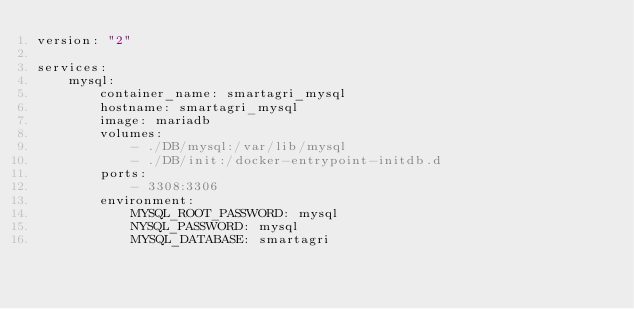Convert code to text. <code><loc_0><loc_0><loc_500><loc_500><_YAML_>version: "2"

services:
    mysql:
        container_name: smartagri_mysql
        hostname: smartagri_mysql
        image: mariadb
        volumes:
            - ./DB/mysql:/var/lib/mysql
            - ./DB/init:/docker-entrypoint-initdb.d
        ports:
            - 3308:3306
        environment:
            MYSQL_ROOT_PASSWORD: mysql
            NYSQL_PASSWORD: mysql
            MYSQL_DATABASE: smartagri
</code> 